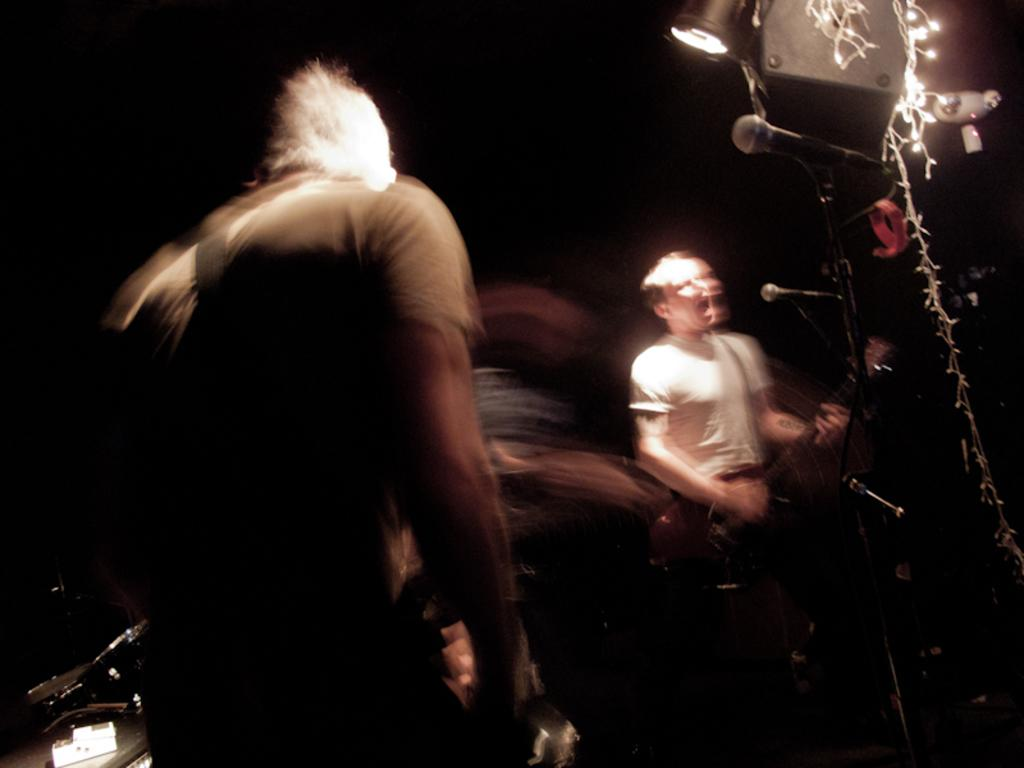What is the man in the image doing? The man is playing a guitar and singing. What instrument is the man using in the image? The man is playing a guitar. What device is present for amplifying the man's voice? There is a microphone in the image. How is the microphone positioned in the image? The microphone has a holder. What is the man's posture in the image? The man is standing. What can be seen in the background that might indicate a performance setting? There are lights visible in the image. What type of salt is being used to season the man's performance in the image? There is no salt present in the image, and the man's performance is not being seasoned. 